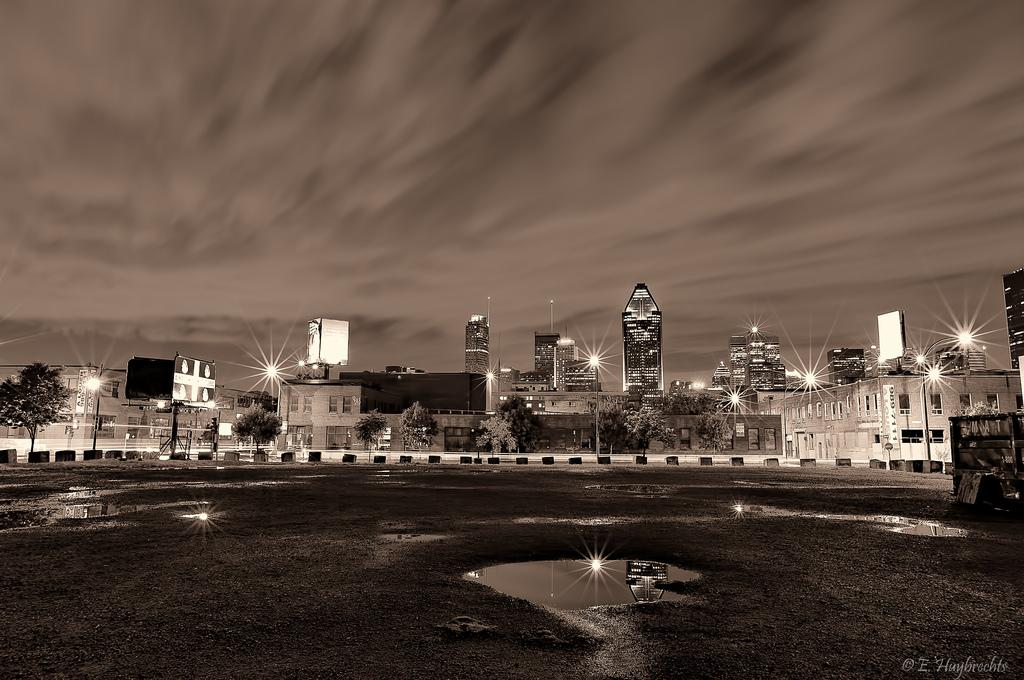What is on the road in the image? There is water on the road in the image. What can be seen near the road in the image? There are trees and light poles near the road in the image. What is visible in the background of the image? There are buildings and the sky in the background of the image. What type of toothpaste is being used to clean the plate in the image? There is no toothpaste or plate present in the image. What are the people talking about in the image? There are no people or conversation depicted in the image. 